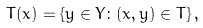<formula> <loc_0><loc_0><loc_500><loc_500>T ( x ) = \{ y \in Y \colon ( x , y ) \in T \} \, ,</formula> 